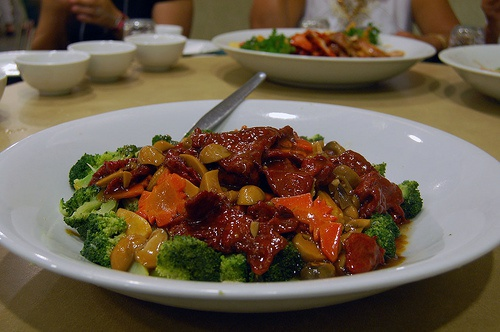Describe the objects in this image and their specific colors. I can see bowl in black, olive, darkgray, and maroon tones, people in black, maroon, and gray tones, people in black, maroon, and brown tones, broccoli in black, darkgreen, and olive tones, and broccoli in black, darkgreen, and olive tones in this image. 